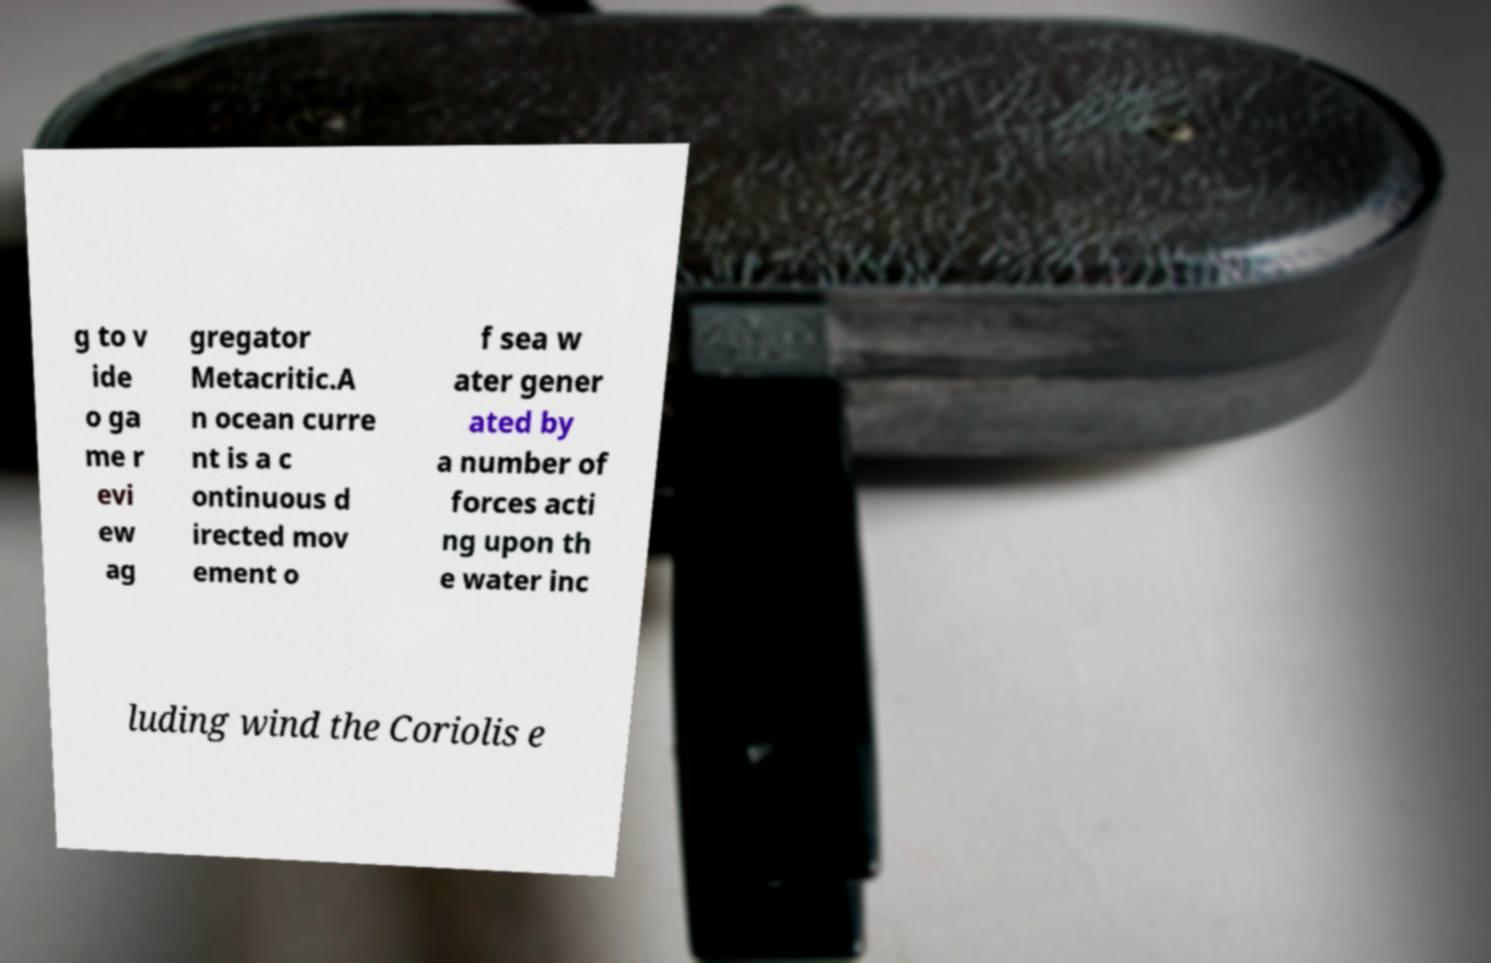I need the written content from this picture converted into text. Can you do that? g to v ide o ga me r evi ew ag gregator Metacritic.A n ocean curre nt is a c ontinuous d irected mov ement o f sea w ater gener ated by a number of forces acti ng upon th e water inc luding wind the Coriolis e 